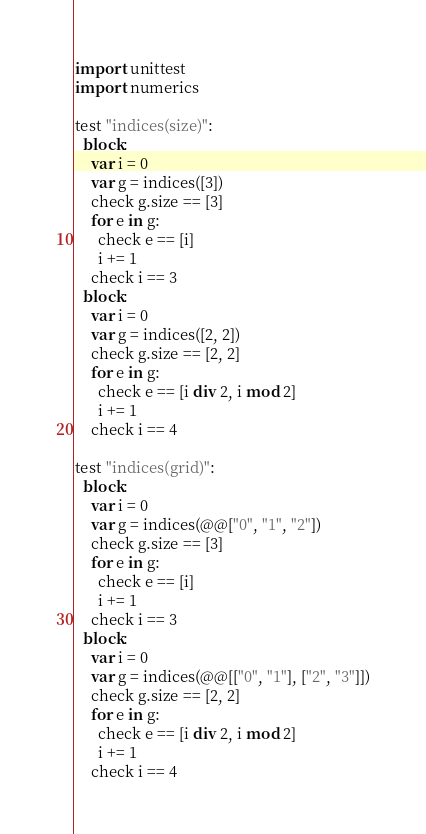Convert code to text. <code><loc_0><loc_0><loc_500><loc_500><_Nim_>import unittest
import numerics

test "indices(size)":
  block:
    var i = 0
    var g = indices([3])
    check g.size == [3]
    for e in g:
      check e == [i]
      i += 1
    check i == 3
  block:
    var i = 0
    var g = indices([2, 2])
    check g.size == [2, 2]
    for e in g:
      check e == [i div 2, i mod 2]
      i += 1
    check i == 4

test "indices(grid)":
  block:
    var i = 0
    var g = indices(@@["0", "1", "2"])
    check g.size == [3]
    for e in g:
      check e == [i]
      i += 1
    check i == 3
  block:
    var i = 0
    var g = indices(@@[["0", "1"], ["2", "3"]])
    check g.size == [2, 2]
    for e in g:
      check e == [i div 2, i mod 2]
      i += 1
    check i == 4
</code> 